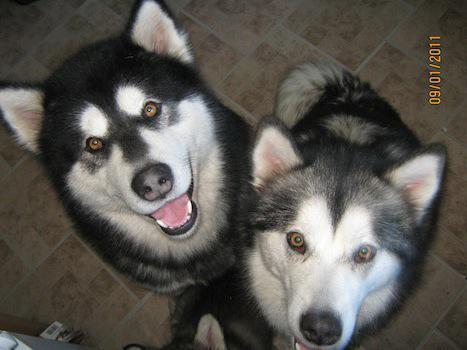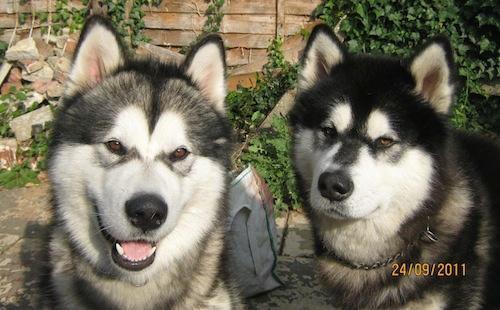The first image is the image on the left, the second image is the image on the right. Assess this claim about the two images: "The left and right image contains the same number of dogs.". Correct or not? Answer yes or no. Yes. 